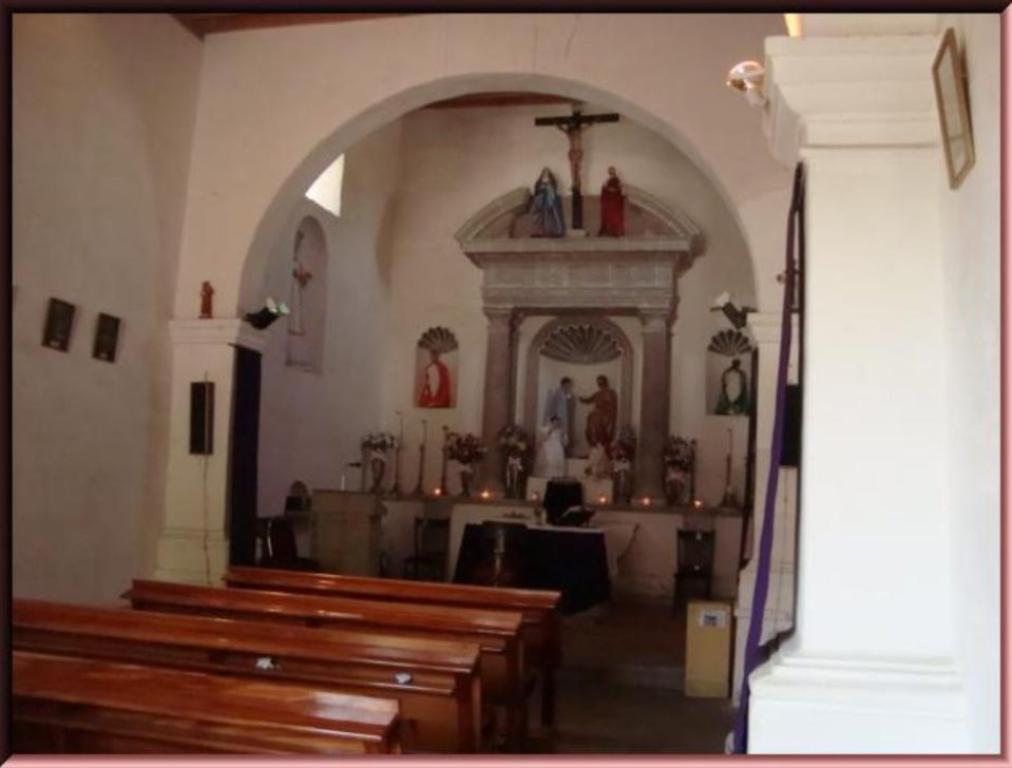What type of location is depicted in the image? The image is an inside view of a church. What type of seating is available in the church? There are benches in the image. What architectural feature can be seen in the image? There is a wall in the image. What is located near the front of the church? There is a podium with a microphone in the image. What type of decoration is present in the church? There are flower bouquets in the image. What type of brick is used to construct the creator's statue in the image? There is no statue or creator present in the image; it is an inside view of a church with benches, a wall, a podium with a microphone, and flower bouquets. 